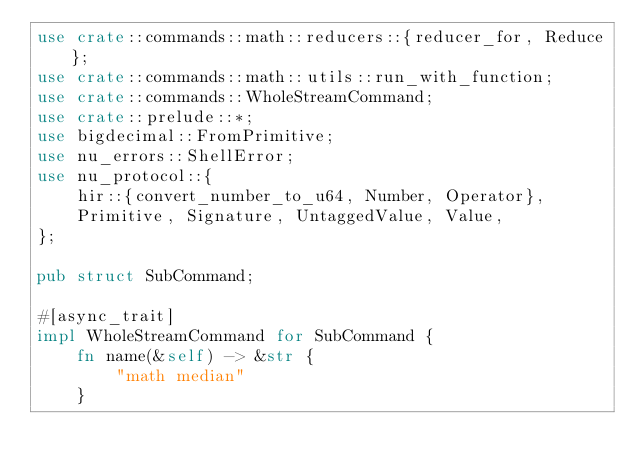Convert code to text. <code><loc_0><loc_0><loc_500><loc_500><_Rust_>use crate::commands::math::reducers::{reducer_for, Reduce};
use crate::commands::math::utils::run_with_function;
use crate::commands::WholeStreamCommand;
use crate::prelude::*;
use bigdecimal::FromPrimitive;
use nu_errors::ShellError;
use nu_protocol::{
    hir::{convert_number_to_u64, Number, Operator},
    Primitive, Signature, UntaggedValue, Value,
};

pub struct SubCommand;

#[async_trait]
impl WholeStreamCommand for SubCommand {
    fn name(&self) -> &str {
        "math median"
    }
</code> 